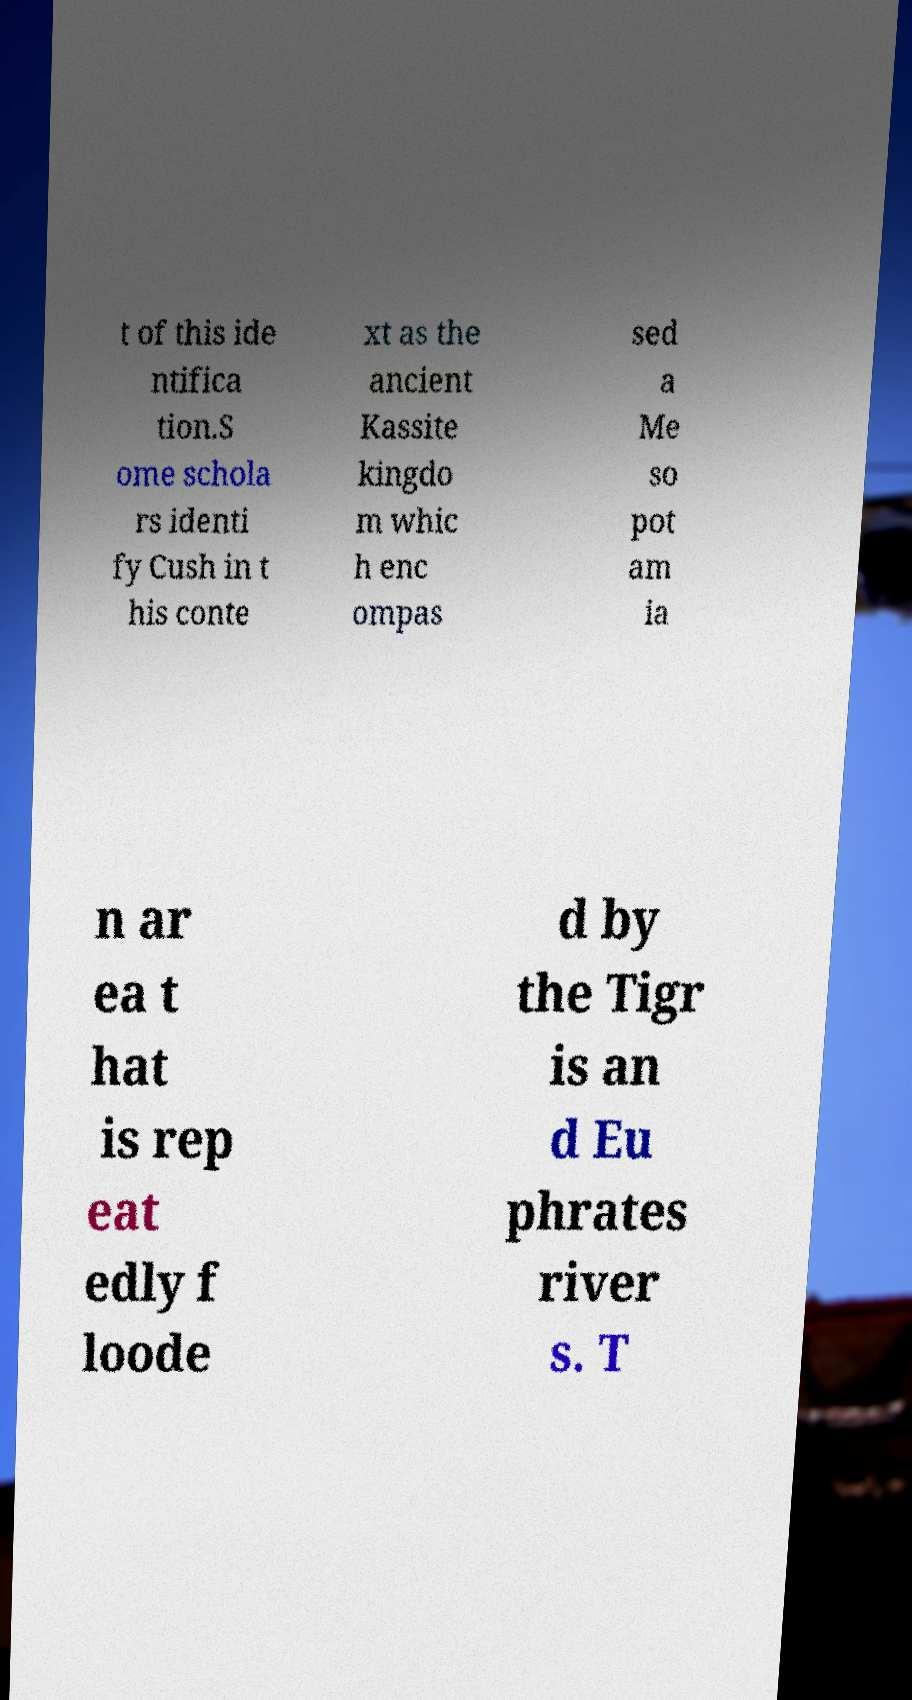Could you extract and type out the text from this image? t of this ide ntifica tion.S ome schola rs identi fy Cush in t his conte xt as the ancient Kassite kingdo m whic h enc ompas sed a Me so pot am ia n ar ea t hat is rep eat edly f loode d by the Tigr is an d Eu phrates river s. T 